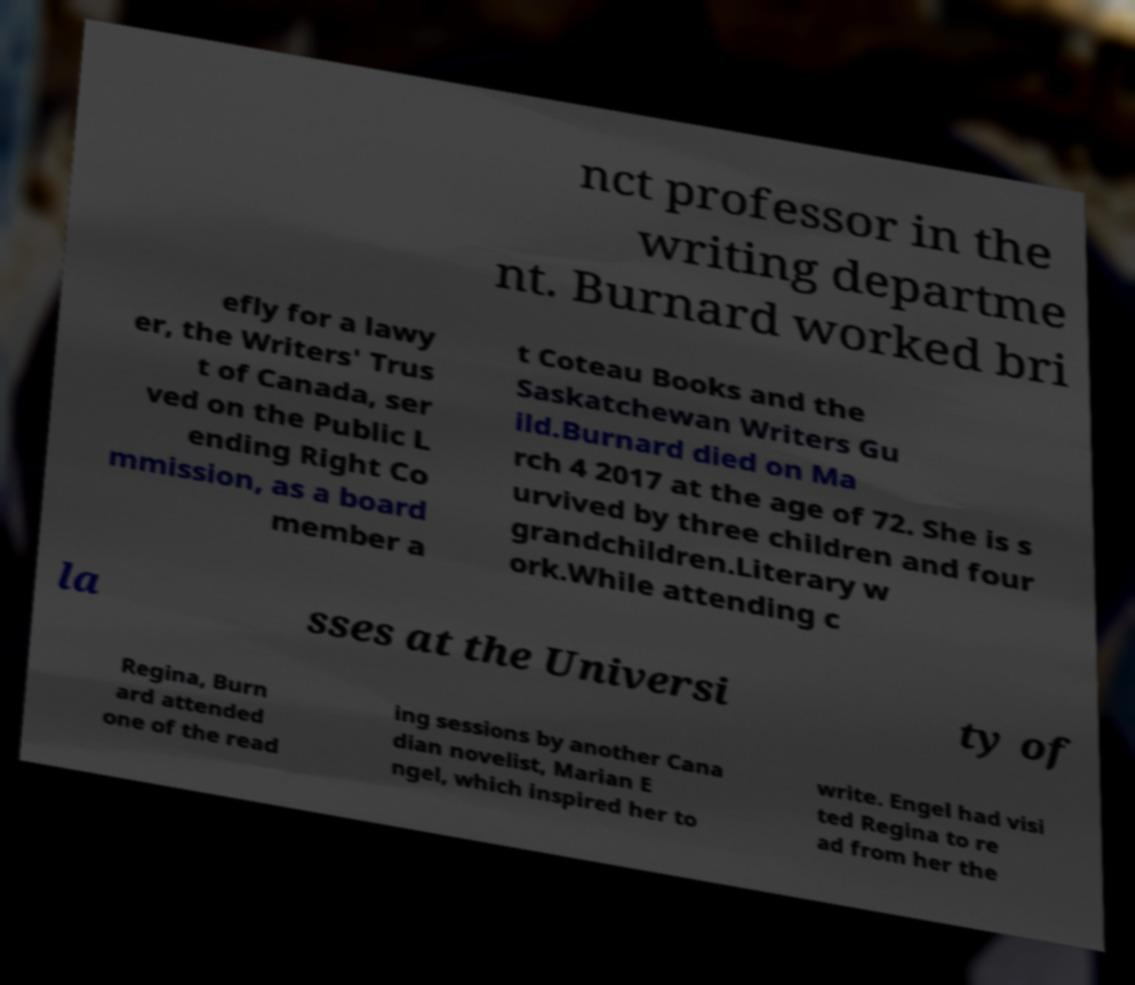Can you accurately transcribe the text from the provided image for me? nct professor in the writing departme nt. Burnard worked bri efly for a lawy er, the Writers' Trus t of Canada, ser ved on the Public L ending Right Co mmission, as a board member a t Coteau Books and the Saskatchewan Writers Gu ild.Burnard died on Ma rch 4 2017 at the age of 72. She is s urvived by three children and four grandchildren.Literary w ork.While attending c la sses at the Universi ty of Regina, Burn ard attended one of the read ing sessions by another Cana dian novelist, Marian E ngel, which inspired her to write. Engel had visi ted Regina to re ad from her the 